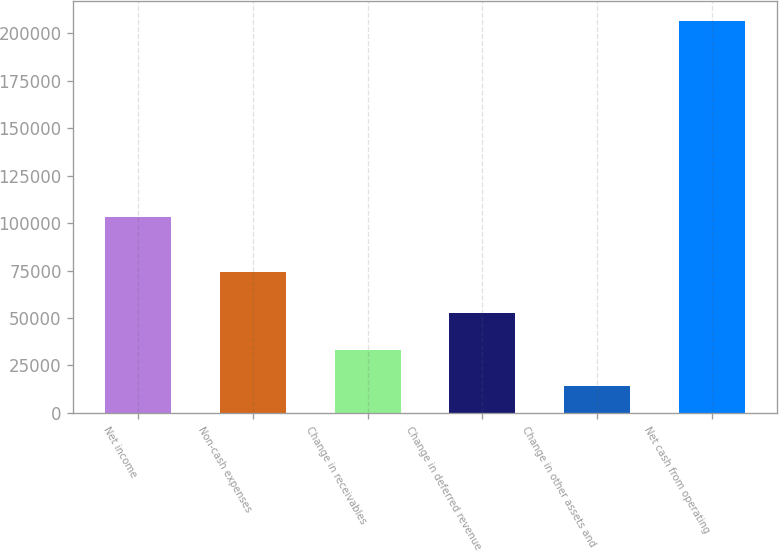Convert chart. <chart><loc_0><loc_0><loc_500><loc_500><bar_chart><fcel>Net income<fcel>Non-cash expenses<fcel>Change in receivables<fcel>Change in deferred revenue<fcel>Change in other assets and<fcel>Net cash from operating<nl><fcel>103102<fcel>74397<fcel>33320<fcel>52572<fcel>14068<fcel>206588<nl></chart> 